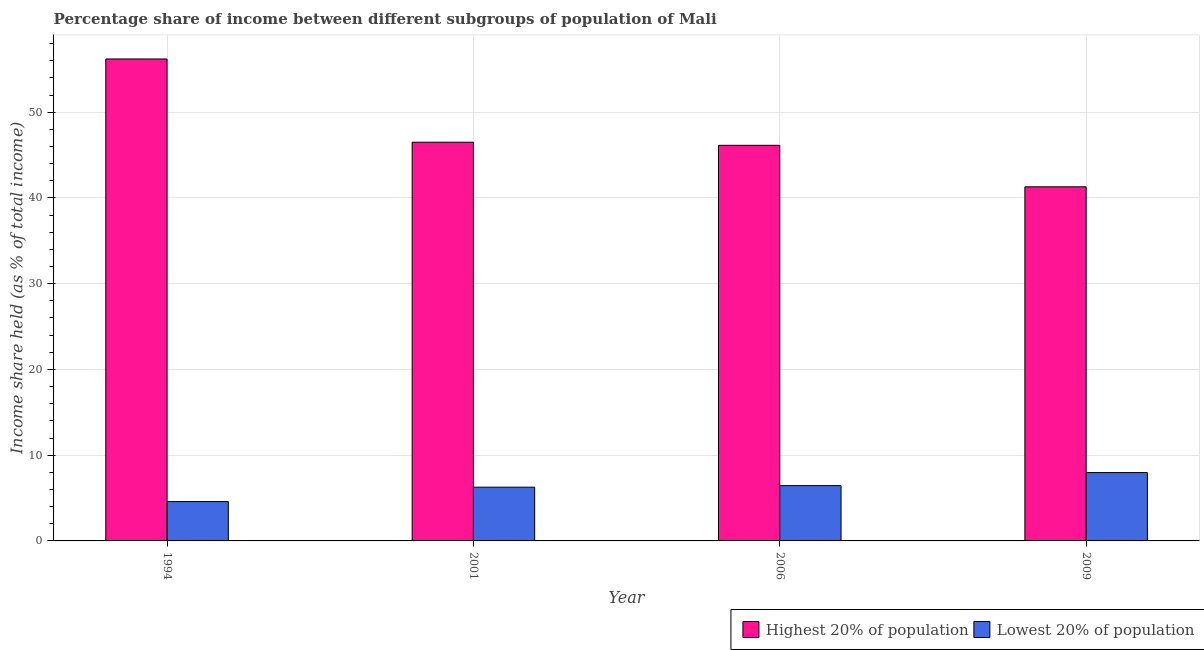How many different coloured bars are there?
Offer a very short reply. 2. How many groups of bars are there?
Ensure brevity in your answer.  4. Are the number of bars on each tick of the X-axis equal?
Provide a short and direct response. Yes. In how many cases, is the number of bars for a given year not equal to the number of legend labels?
Your answer should be compact. 0. What is the income share held by lowest 20% of the population in 2009?
Provide a short and direct response. 7.97. Across all years, what is the maximum income share held by highest 20% of the population?
Your answer should be compact. 56.21. Across all years, what is the minimum income share held by highest 20% of the population?
Offer a terse response. 41.3. In which year was the income share held by highest 20% of the population minimum?
Provide a succinct answer. 2009. What is the total income share held by highest 20% of the population in the graph?
Give a very brief answer. 190.15. What is the difference between the income share held by highest 20% of the population in 1994 and that in 2009?
Give a very brief answer. 14.91. What is the difference between the income share held by highest 20% of the population in 2001 and the income share held by lowest 20% of the population in 2006?
Your answer should be very brief. 0.36. What is the average income share held by lowest 20% of the population per year?
Your answer should be very brief. 6.32. What is the ratio of the income share held by lowest 20% of the population in 1994 to that in 2006?
Provide a short and direct response. 0.71. What is the difference between the highest and the second highest income share held by lowest 20% of the population?
Give a very brief answer. 1.52. What is the difference between the highest and the lowest income share held by lowest 20% of the population?
Provide a short and direct response. 3.38. In how many years, is the income share held by highest 20% of the population greater than the average income share held by highest 20% of the population taken over all years?
Offer a terse response. 1. Is the sum of the income share held by lowest 20% of the population in 1994 and 2006 greater than the maximum income share held by highest 20% of the population across all years?
Offer a very short reply. Yes. What does the 2nd bar from the left in 2009 represents?
Keep it short and to the point. Lowest 20% of population. What does the 2nd bar from the right in 2009 represents?
Offer a terse response. Highest 20% of population. Are all the bars in the graph horizontal?
Keep it short and to the point. No. How many years are there in the graph?
Give a very brief answer. 4. What is the difference between two consecutive major ticks on the Y-axis?
Offer a very short reply. 10. Does the graph contain any zero values?
Offer a very short reply. No. Does the graph contain grids?
Provide a short and direct response. Yes. How many legend labels are there?
Offer a very short reply. 2. How are the legend labels stacked?
Your answer should be very brief. Horizontal. What is the title of the graph?
Ensure brevity in your answer.  Percentage share of income between different subgroups of population of Mali. Does "Investment in Transport" appear as one of the legend labels in the graph?
Keep it short and to the point. No. What is the label or title of the X-axis?
Provide a succinct answer. Year. What is the label or title of the Y-axis?
Your response must be concise. Income share held (as % of total income). What is the Income share held (as % of total income) in Highest 20% of population in 1994?
Your answer should be very brief. 56.21. What is the Income share held (as % of total income) in Lowest 20% of population in 1994?
Keep it short and to the point. 4.59. What is the Income share held (as % of total income) of Highest 20% of population in 2001?
Give a very brief answer. 46.5. What is the Income share held (as % of total income) in Lowest 20% of population in 2001?
Your answer should be very brief. 6.27. What is the Income share held (as % of total income) in Highest 20% of population in 2006?
Keep it short and to the point. 46.14. What is the Income share held (as % of total income) of Lowest 20% of population in 2006?
Provide a short and direct response. 6.45. What is the Income share held (as % of total income) in Highest 20% of population in 2009?
Offer a terse response. 41.3. What is the Income share held (as % of total income) in Lowest 20% of population in 2009?
Provide a short and direct response. 7.97. Across all years, what is the maximum Income share held (as % of total income) of Highest 20% of population?
Offer a very short reply. 56.21. Across all years, what is the maximum Income share held (as % of total income) of Lowest 20% of population?
Ensure brevity in your answer.  7.97. Across all years, what is the minimum Income share held (as % of total income) of Highest 20% of population?
Make the answer very short. 41.3. Across all years, what is the minimum Income share held (as % of total income) of Lowest 20% of population?
Provide a short and direct response. 4.59. What is the total Income share held (as % of total income) in Highest 20% of population in the graph?
Provide a succinct answer. 190.15. What is the total Income share held (as % of total income) in Lowest 20% of population in the graph?
Offer a terse response. 25.28. What is the difference between the Income share held (as % of total income) in Highest 20% of population in 1994 and that in 2001?
Keep it short and to the point. 9.71. What is the difference between the Income share held (as % of total income) of Lowest 20% of population in 1994 and that in 2001?
Provide a succinct answer. -1.68. What is the difference between the Income share held (as % of total income) of Highest 20% of population in 1994 and that in 2006?
Your response must be concise. 10.07. What is the difference between the Income share held (as % of total income) in Lowest 20% of population in 1994 and that in 2006?
Ensure brevity in your answer.  -1.86. What is the difference between the Income share held (as % of total income) of Highest 20% of population in 1994 and that in 2009?
Your answer should be very brief. 14.91. What is the difference between the Income share held (as % of total income) in Lowest 20% of population in 1994 and that in 2009?
Your answer should be very brief. -3.38. What is the difference between the Income share held (as % of total income) in Highest 20% of population in 2001 and that in 2006?
Keep it short and to the point. 0.36. What is the difference between the Income share held (as % of total income) in Lowest 20% of population in 2001 and that in 2006?
Your answer should be compact. -0.18. What is the difference between the Income share held (as % of total income) in Highest 20% of population in 2006 and that in 2009?
Provide a short and direct response. 4.84. What is the difference between the Income share held (as % of total income) in Lowest 20% of population in 2006 and that in 2009?
Ensure brevity in your answer.  -1.52. What is the difference between the Income share held (as % of total income) in Highest 20% of population in 1994 and the Income share held (as % of total income) in Lowest 20% of population in 2001?
Your response must be concise. 49.94. What is the difference between the Income share held (as % of total income) of Highest 20% of population in 1994 and the Income share held (as % of total income) of Lowest 20% of population in 2006?
Provide a short and direct response. 49.76. What is the difference between the Income share held (as % of total income) in Highest 20% of population in 1994 and the Income share held (as % of total income) in Lowest 20% of population in 2009?
Your answer should be very brief. 48.24. What is the difference between the Income share held (as % of total income) of Highest 20% of population in 2001 and the Income share held (as % of total income) of Lowest 20% of population in 2006?
Your answer should be very brief. 40.05. What is the difference between the Income share held (as % of total income) of Highest 20% of population in 2001 and the Income share held (as % of total income) of Lowest 20% of population in 2009?
Give a very brief answer. 38.53. What is the difference between the Income share held (as % of total income) of Highest 20% of population in 2006 and the Income share held (as % of total income) of Lowest 20% of population in 2009?
Offer a very short reply. 38.17. What is the average Income share held (as % of total income) of Highest 20% of population per year?
Provide a succinct answer. 47.54. What is the average Income share held (as % of total income) of Lowest 20% of population per year?
Give a very brief answer. 6.32. In the year 1994, what is the difference between the Income share held (as % of total income) in Highest 20% of population and Income share held (as % of total income) in Lowest 20% of population?
Provide a succinct answer. 51.62. In the year 2001, what is the difference between the Income share held (as % of total income) in Highest 20% of population and Income share held (as % of total income) in Lowest 20% of population?
Your answer should be compact. 40.23. In the year 2006, what is the difference between the Income share held (as % of total income) of Highest 20% of population and Income share held (as % of total income) of Lowest 20% of population?
Provide a succinct answer. 39.69. In the year 2009, what is the difference between the Income share held (as % of total income) in Highest 20% of population and Income share held (as % of total income) in Lowest 20% of population?
Offer a very short reply. 33.33. What is the ratio of the Income share held (as % of total income) in Highest 20% of population in 1994 to that in 2001?
Your response must be concise. 1.21. What is the ratio of the Income share held (as % of total income) of Lowest 20% of population in 1994 to that in 2001?
Make the answer very short. 0.73. What is the ratio of the Income share held (as % of total income) in Highest 20% of population in 1994 to that in 2006?
Offer a terse response. 1.22. What is the ratio of the Income share held (as % of total income) of Lowest 20% of population in 1994 to that in 2006?
Make the answer very short. 0.71. What is the ratio of the Income share held (as % of total income) of Highest 20% of population in 1994 to that in 2009?
Offer a terse response. 1.36. What is the ratio of the Income share held (as % of total income) of Lowest 20% of population in 1994 to that in 2009?
Provide a succinct answer. 0.58. What is the ratio of the Income share held (as % of total income) in Highest 20% of population in 2001 to that in 2006?
Provide a succinct answer. 1.01. What is the ratio of the Income share held (as % of total income) of Lowest 20% of population in 2001 to that in 2006?
Ensure brevity in your answer.  0.97. What is the ratio of the Income share held (as % of total income) in Highest 20% of population in 2001 to that in 2009?
Keep it short and to the point. 1.13. What is the ratio of the Income share held (as % of total income) in Lowest 20% of population in 2001 to that in 2009?
Keep it short and to the point. 0.79. What is the ratio of the Income share held (as % of total income) of Highest 20% of population in 2006 to that in 2009?
Give a very brief answer. 1.12. What is the ratio of the Income share held (as % of total income) of Lowest 20% of population in 2006 to that in 2009?
Ensure brevity in your answer.  0.81. What is the difference between the highest and the second highest Income share held (as % of total income) of Highest 20% of population?
Offer a terse response. 9.71. What is the difference between the highest and the second highest Income share held (as % of total income) in Lowest 20% of population?
Make the answer very short. 1.52. What is the difference between the highest and the lowest Income share held (as % of total income) of Highest 20% of population?
Your answer should be compact. 14.91. What is the difference between the highest and the lowest Income share held (as % of total income) of Lowest 20% of population?
Offer a terse response. 3.38. 